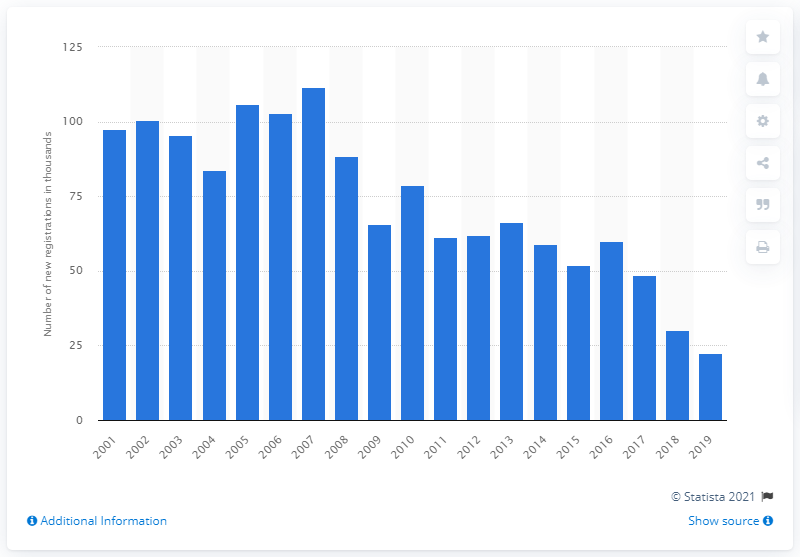Indicate a few pertinent items in this graphic. A peak in sales of the Vauxhall Astra was observed in 2007. 